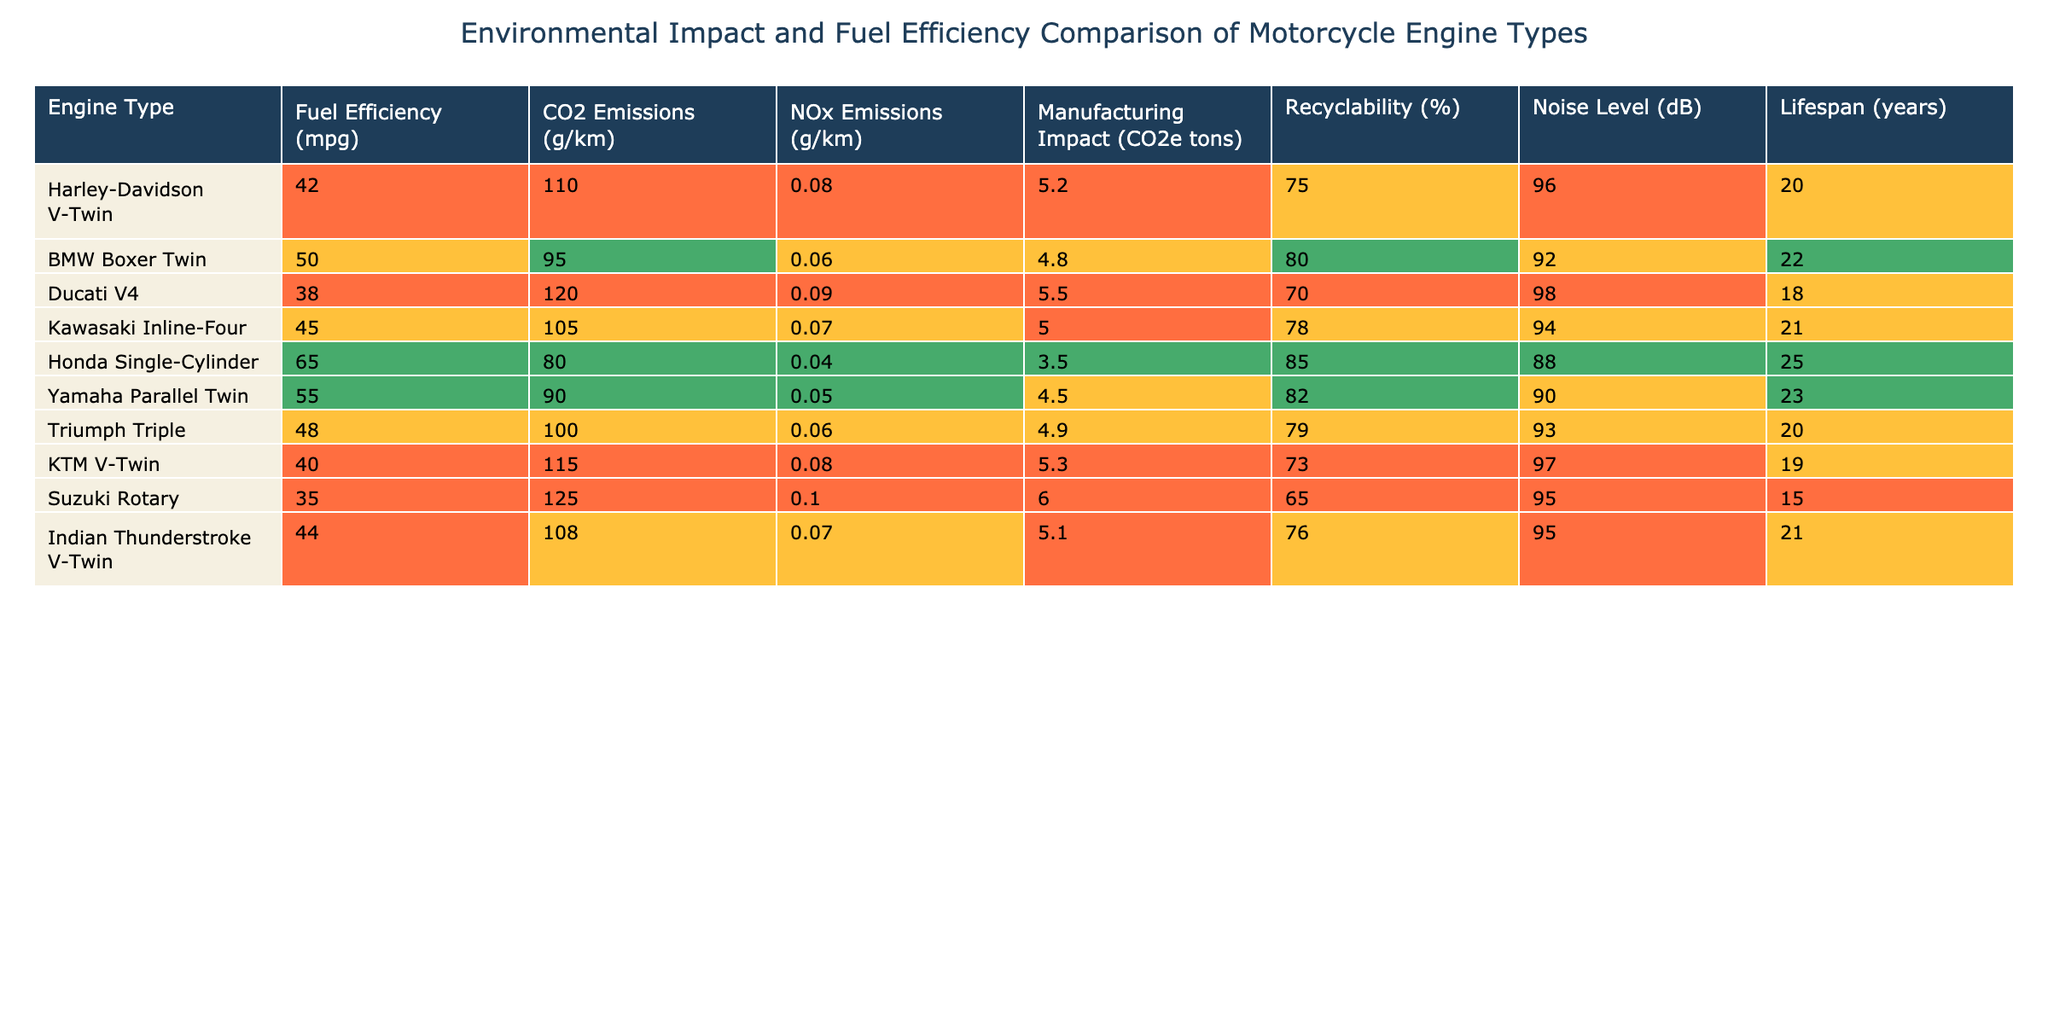What is the fuel efficiency of the Honda Single-Cylinder? According to the table, the fuel efficiency of the Honda Single-Cylinder is listed as 65 mpg.
Answer: 65 mpg Which motorcycle has the highest CO2 emissions? The table shows that the Suzuki Rotary has the highest CO2 emissions figure at 125 g/km.
Answer: Suzuki Rotary Is the Harley-Davidson V-Twin more recyclable than the BMW Boxer Twin? The Harley-Davidson V-Twin has 75% recyclability, while the BMW Boxer Twin has 80%. Since 75% is less than 80%, the Harley-Davidson V-Twin is less recyclable.
Answer: No What is the average lifespan of the motorcycles in the table? The lifespans of the motorcycles are 20, 22, 18, 21, 25, 23, 20, 19, 15, and 21 years. Adding these values gives a total of 204 years, divided by 10 motorcycles results in an average lifespan of 20.4 years.
Answer: 20.4 years Which motorcycle has the lowest NOx emissions and what is the value? The Honda Single-Cylinder has the lowest NOx emissions at 0.04 g/km, which is the smallest recorded value in the table.
Answer: 0.04 g/km Is the fuel efficiency of the Yamaha Parallel Twin greater than that of the Ducati V4? The Yamaha Parallel Twin has a fuel efficiency of 55 mpg, while the Ducati V4 has 38 mpg. Since 55 is greater than 38, the statement is true.
Answer: Yes What is the difference in CO2 emissions between the BMW Boxer Twin and the KTM V-Twin? The CO2 emissions for the BMW Boxer Twin is 95 g/km and for the KTM V-Twin it's 115 g/km. The difference is 115 - 95 = 20 g/km.
Answer: 20 g/km How many motorcycles have a lifespan longer than 20 years? Looking at the lifespan column, the motorcycles with a lifespan longer than 20 years are the Honda Single-Cylinder (25 years) and the Yamaha Parallel Twin (23 years). That totals to 2 motorcycles.
Answer: 2 Which motorcycle type has the highest noise level and what is that level? The table shows the noise levels, and the Kawasaki Inline-Four has the highest level at 94 dB, which is the greatest figure listed.
Answer: 94 dB 